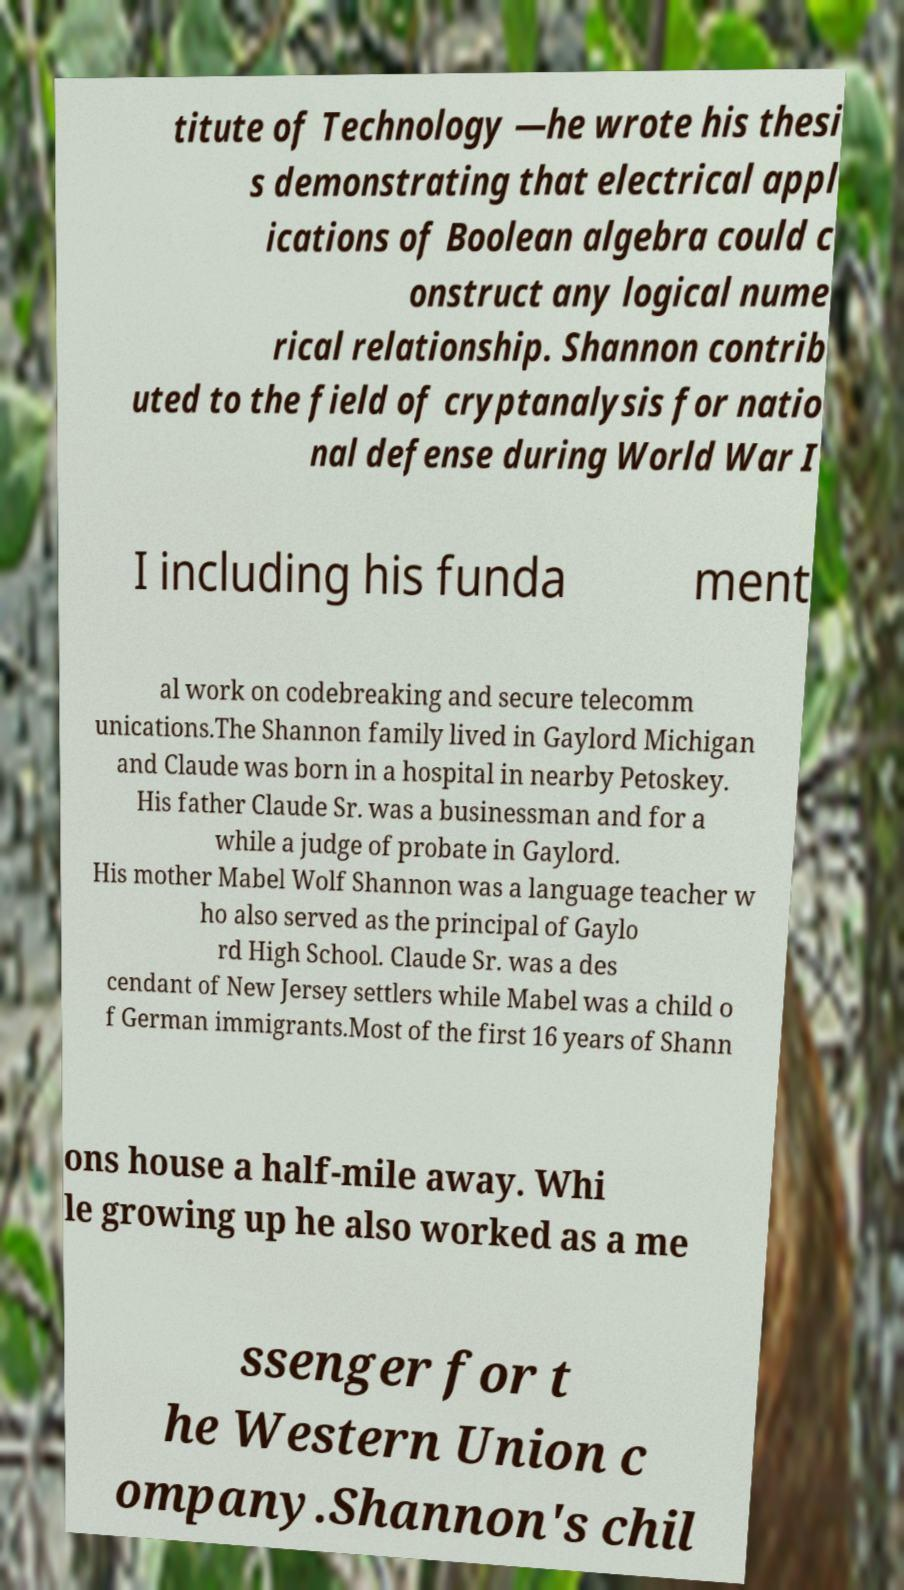For documentation purposes, I need the text within this image transcribed. Could you provide that? titute of Technology —he wrote his thesi s demonstrating that electrical appl ications of Boolean algebra could c onstruct any logical nume rical relationship. Shannon contrib uted to the field of cryptanalysis for natio nal defense during World War I I including his funda ment al work on codebreaking and secure telecomm unications.The Shannon family lived in Gaylord Michigan and Claude was born in a hospital in nearby Petoskey. His father Claude Sr. was a businessman and for a while a judge of probate in Gaylord. His mother Mabel Wolf Shannon was a language teacher w ho also served as the principal of Gaylo rd High School. Claude Sr. was a des cendant of New Jersey settlers while Mabel was a child o f German immigrants.Most of the first 16 years of Shann ons house a half-mile away. Whi le growing up he also worked as a me ssenger for t he Western Union c ompany.Shannon's chil 